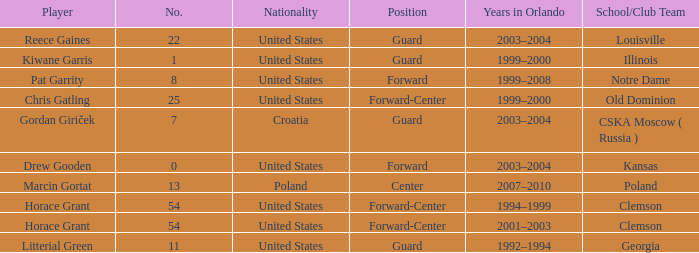How many members are there in notre dame's team? 1.0. 